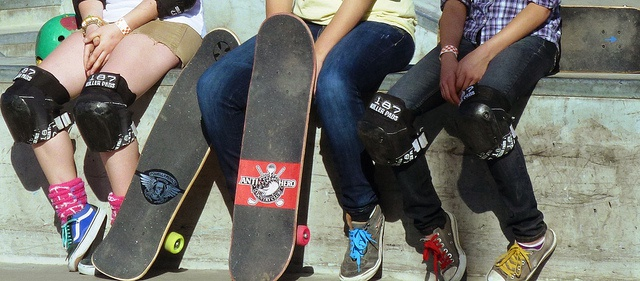Describe the objects in this image and their specific colors. I can see people in gray, black, darkgray, and maroon tones, people in gray, black, lightgray, and tan tones, people in gray, black, navy, and blue tones, skateboard in gray, salmon, lightgray, and black tones, and skateboard in gray, black, tan, and blue tones in this image. 